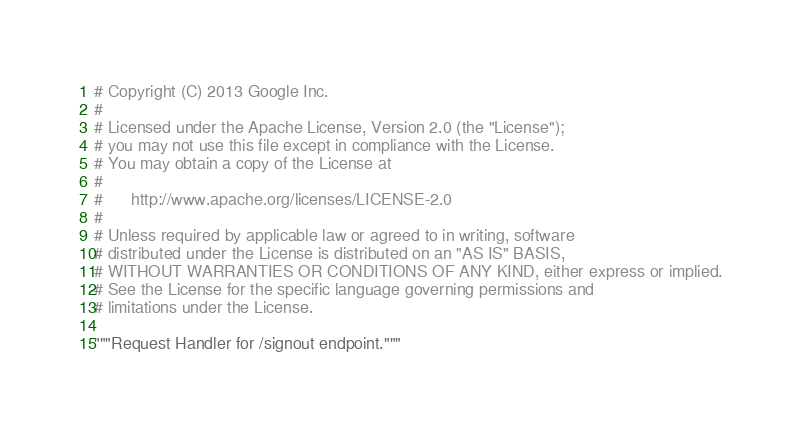<code> <loc_0><loc_0><loc_500><loc_500><_Python_># Copyright (C) 2013 Google Inc.
#
# Licensed under the Apache License, Version 2.0 (the "License");
# you may not use this file except in compliance with the License.
# You may obtain a copy of the License at
#
#      http://www.apache.org/licenses/LICENSE-2.0
#
# Unless required by applicable law or agreed to in writing, software
# distributed under the License is distributed on an "AS IS" BASIS,
# WITHOUT WARRANTIES OR CONDITIONS OF ANY KIND, either express or implied.
# See the License for the specific language governing permissions and
# limitations under the License.

"""Request Handler for /signout endpoint."""
</code> 